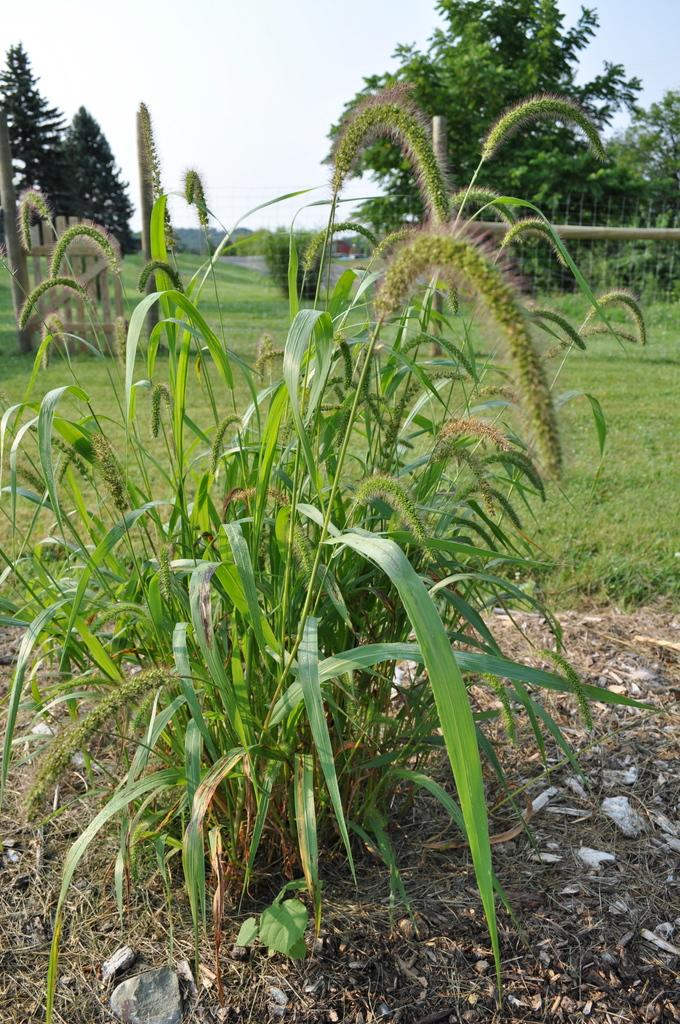What type of vegetation can be seen in the image? There are trees in the image. What is on the ground in the image? There is grass on the ground in the image. What other plant is visible in the image? There is a plant in the image. How would you describe the sky in the image? The sky is blue and cloudy in the image. What structure can be seen in the background of the image? There is a wooden gate in the background of the image. Can you see a necklace hanging from the tree in the image? There is no necklace present in the image. Is there a playground visible in the image? There is no playground present in the image. 